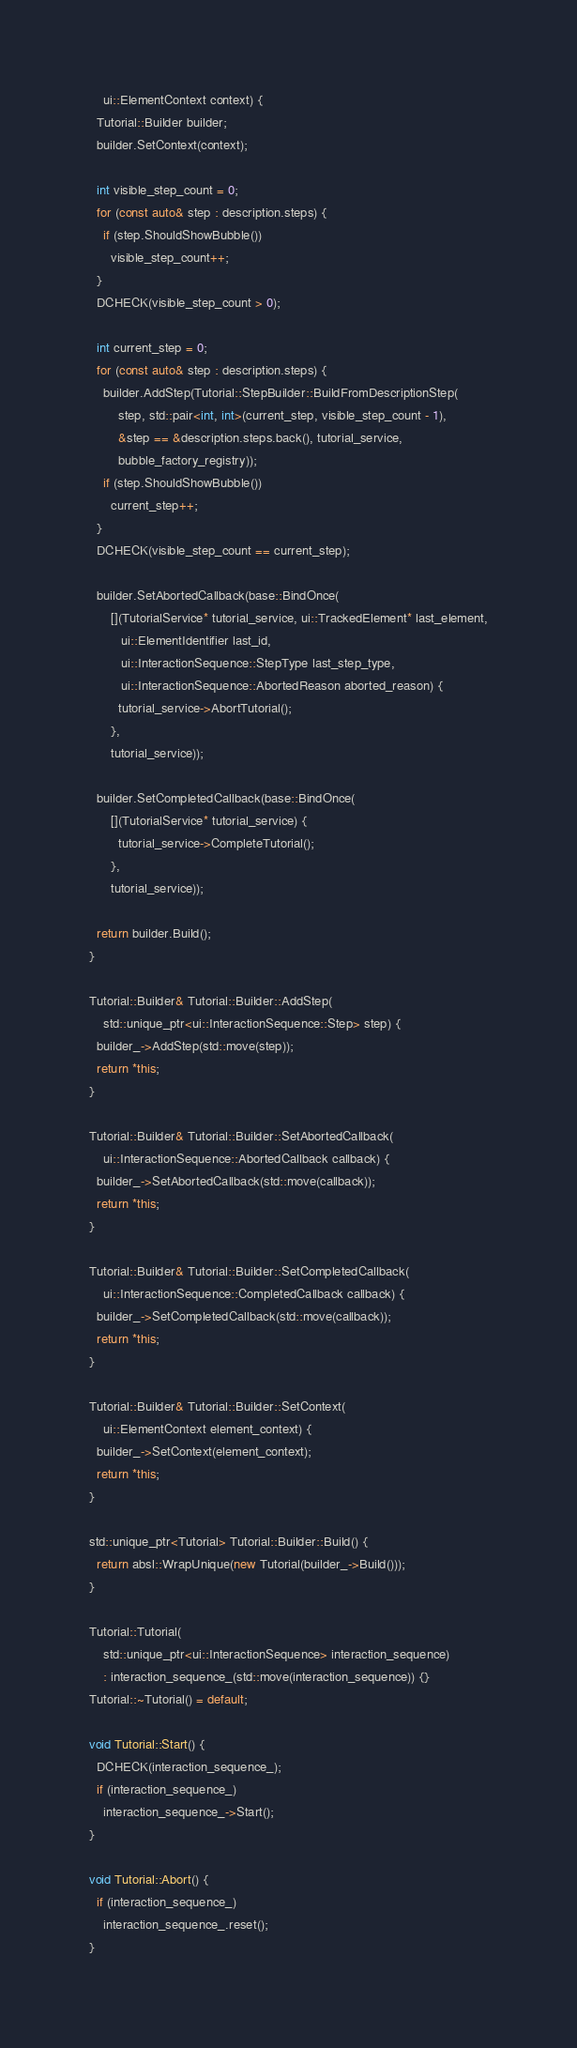<code> <loc_0><loc_0><loc_500><loc_500><_C++_>    ui::ElementContext context) {
  Tutorial::Builder builder;
  builder.SetContext(context);

  int visible_step_count = 0;
  for (const auto& step : description.steps) {
    if (step.ShouldShowBubble())
      visible_step_count++;
  }
  DCHECK(visible_step_count > 0);

  int current_step = 0;
  for (const auto& step : description.steps) {
    builder.AddStep(Tutorial::StepBuilder::BuildFromDescriptionStep(
        step, std::pair<int, int>(current_step, visible_step_count - 1),
        &step == &description.steps.back(), tutorial_service,
        bubble_factory_registry));
    if (step.ShouldShowBubble())
      current_step++;
  }
  DCHECK(visible_step_count == current_step);

  builder.SetAbortedCallback(base::BindOnce(
      [](TutorialService* tutorial_service, ui::TrackedElement* last_element,
         ui::ElementIdentifier last_id,
         ui::InteractionSequence::StepType last_step_type,
         ui::InteractionSequence::AbortedReason aborted_reason) {
        tutorial_service->AbortTutorial();
      },
      tutorial_service));

  builder.SetCompletedCallback(base::BindOnce(
      [](TutorialService* tutorial_service) {
        tutorial_service->CompleteTutorial();
      },
      tutorial_service));

  return builder.Build();
}

Tutorial::Builder& Tutorial::Builder::AddStep(
    std::unique_ptr<ui::InteractionSequence::Step> step) {
  builder_->AddStep(std::move(step));
  return *this;
}

Tutorial::Builder& Tutorial::Builder::SetAbortedCallback(
    ui::InteractionSequence::AbortedCallback callback) {
  builder_->SetAbortedCallback(std::move(callback));
  return *this;
}

Tutorial::Builder& Tutorial::Builder::SetCompletedCallback(
    ui::InteractionSequence::CompletedCallback callback) {
  builder_->SetCompletedCallback(std::move(callback));
  return *this;
}

Tutorial::Builder& Tutorial::Builder::SetContext(
    ui::ElementContext element_context) {
  builder_->SetContext(element_context);
  return *this;
}

std::unique_ptr<Tutorial> Tutorial::Builder::Build() {
  return absl::WrapUnique(new Tutorial(builder_->Build()));
}

Tutorial::Tutorial(
    std::unique_ptr<ui::InteractionSequence> interaction_sequence)
    : interaction_sequence_(std::move(interaction_sequence)) {}
Tutorial::~Tutorial() = default;

void Tutorial::Start() {
  DCHECK(interaction_sequence_);
  if (interaction_sequence_)
    interaction_sequence_->Start();
}

void Tutorial::Abort() {
  if (interaction_sequence_)
    interaction_sequence_.reset();
}
</code> 